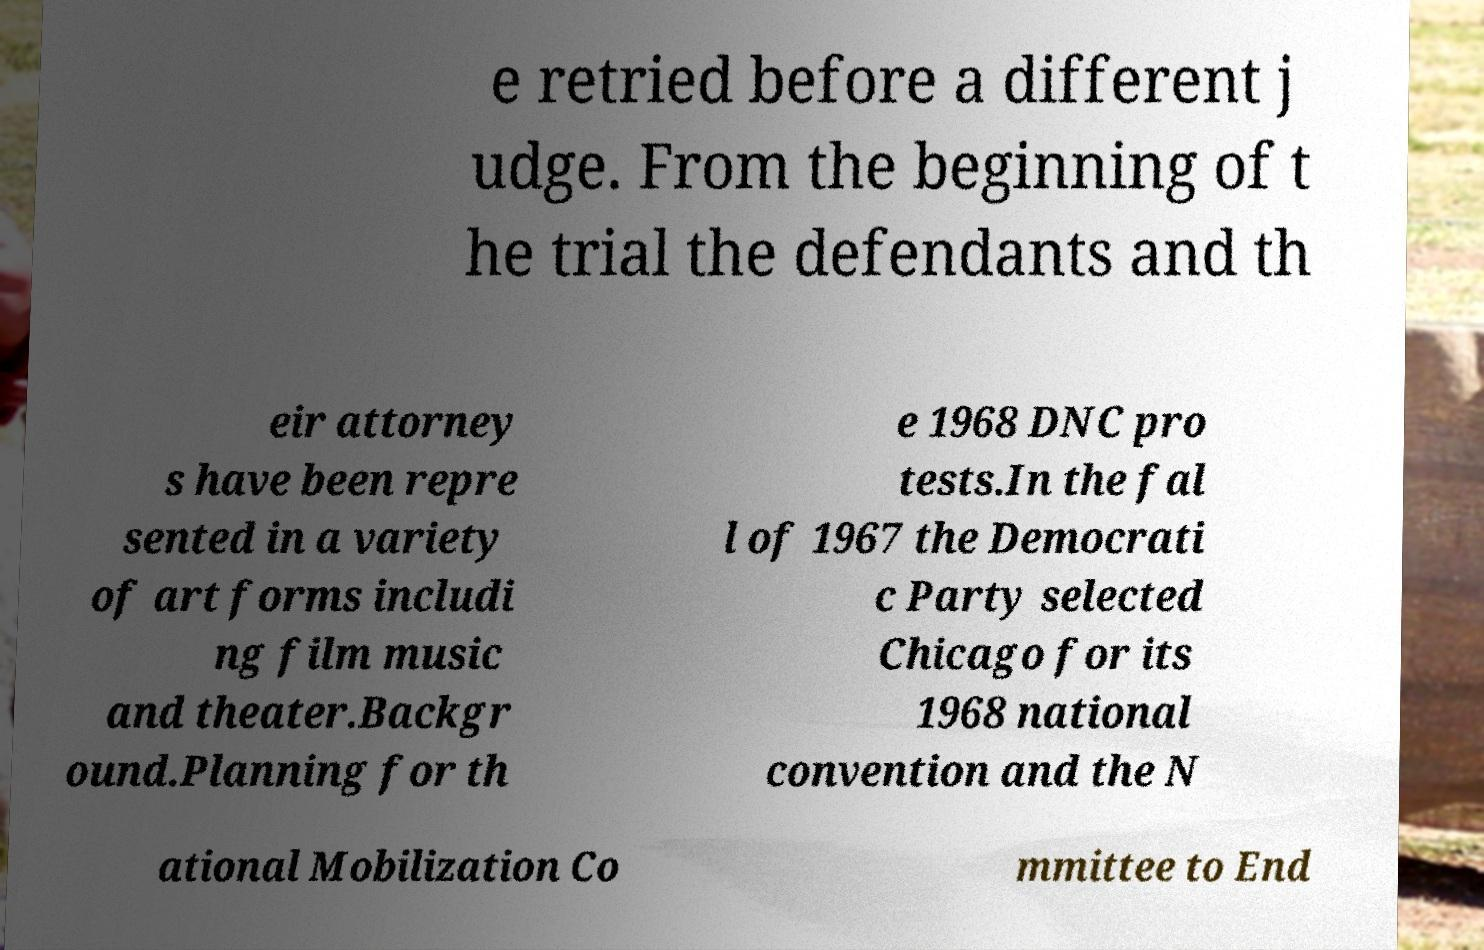Can you accurately transcribe the text from the provided image for me? e retried before a different j udge. From the beginning of t he trial the defendants and th eir attorney s have been repre sented in a variety of art forms includi ng film music and theater.Backgr ound.Planning for th e 1968 DNC pro tests.In the fal l of 1967 the Democrati c Party selected Chicago for its 1968 national convention and the N ational Mobilization Co mmittee to End 